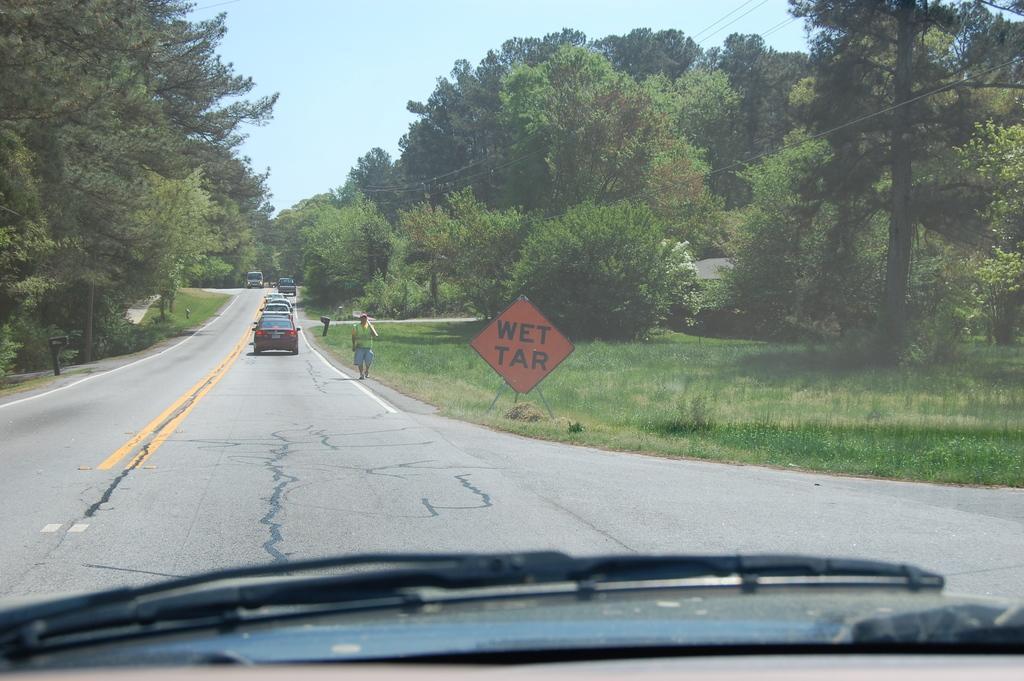Describe this image in one or two sentences. In this image we can see some vehicles on the road and a person walking. We can also see a group of trees, a board with a stand, wires and the sky which looks cloudy. 